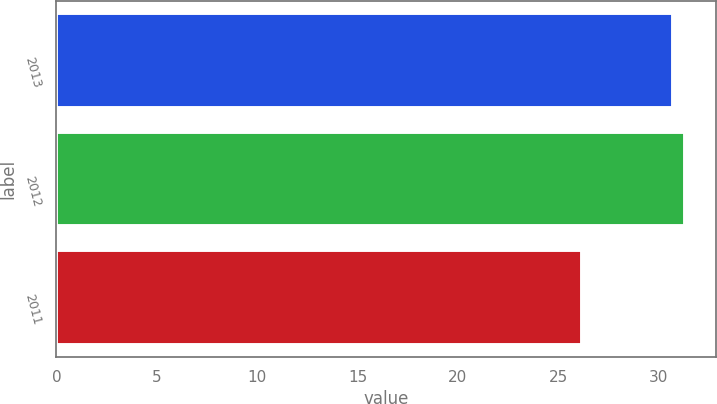Convert chart. <chart><loc_0><loc_0><loc_500><loc_500><bar_chart><fcel>2013<fcel>2012<fcel>2011<nl><fcel>30.7<fcel>31.3<fcel>26.2<nl></chart> 